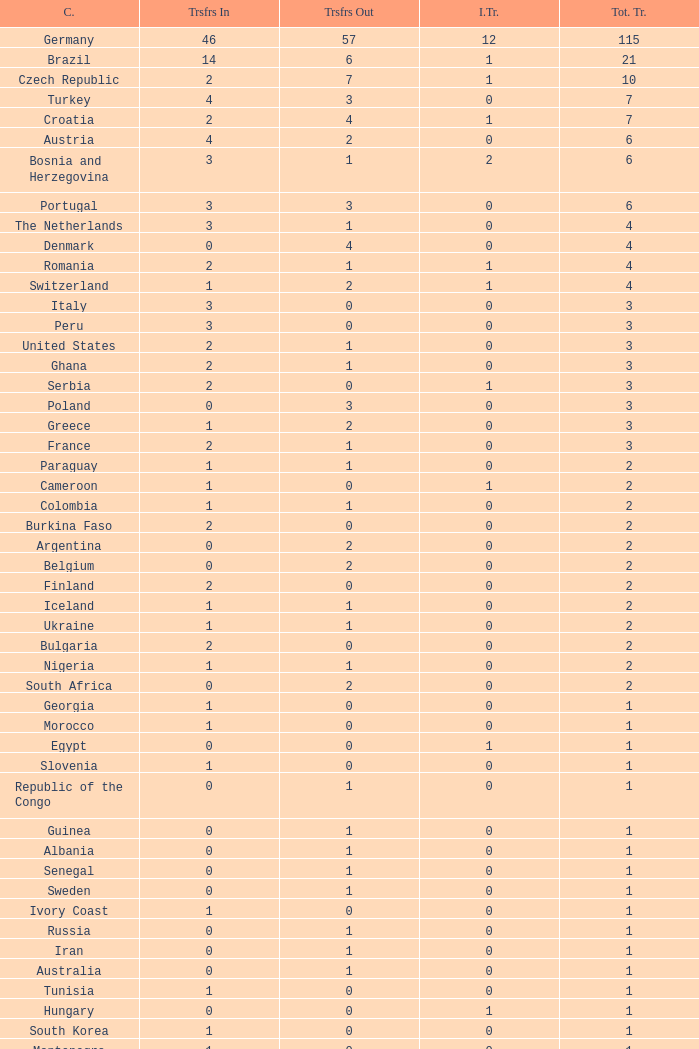What are the transfers in for Hungary? 0.0. 